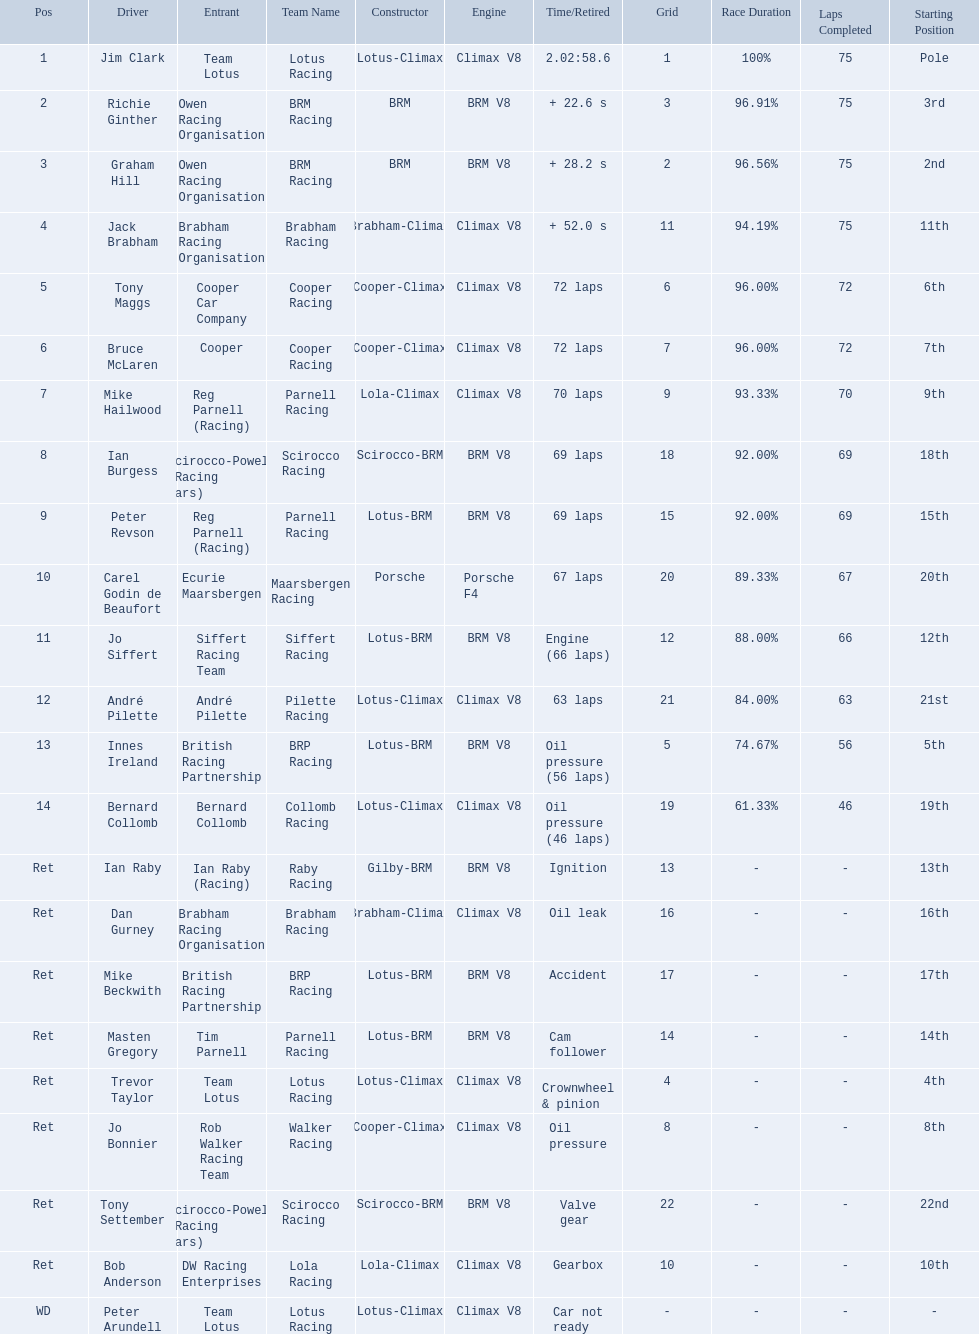Who were the drivers at the 1963 international gold cup? Jim Clark, Richie Ginther, Graham Hill, Jack Brabham, Tony Maggs, Bruce McLaren, Mike Hailwood, Ian Burgess, Peter Revson, Carel Godin de Beaufort, Jo Siffert, André Pilette, Innes Ireland, Bernard Collomb, Ian Raby, Dan Gurney, Mike Beckwith, Masten Gregory, Trevor Taylor, Jo Bonnier, Tony Settember, Bob Anderson, Peter Arundell. What was tony maggs position? 5. What was jo siffert? 11. Who came in earlier? Tony Maggs. 